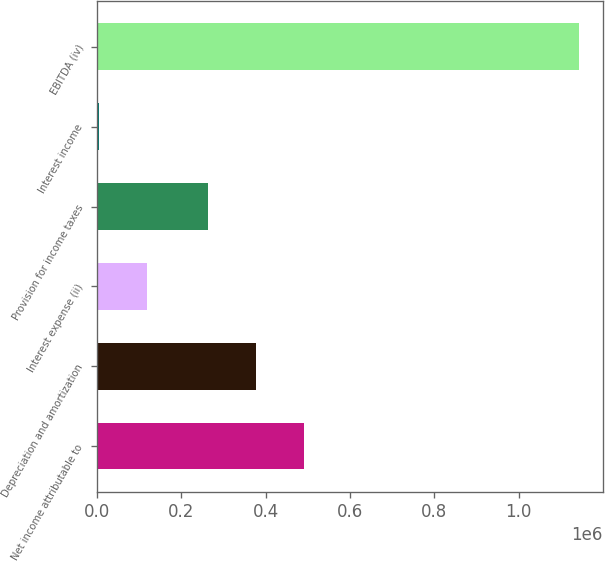Convert chart to OTSL. <chart><loc_0><loc_0><loc_500><loc_500><bar_chart><fcel>Net income attributable to<fcel>Depreciation and amortization<fcel>Interest expense (ii)<fcel>Provision for income taxes<fcel>Interest income<fcel>EBITDA (iv)<nl><fcel>490963<fcel>377361<fcel>119835<fcel>263759<fcel>6233<fcel>1.14225e+06<nl></chart> 